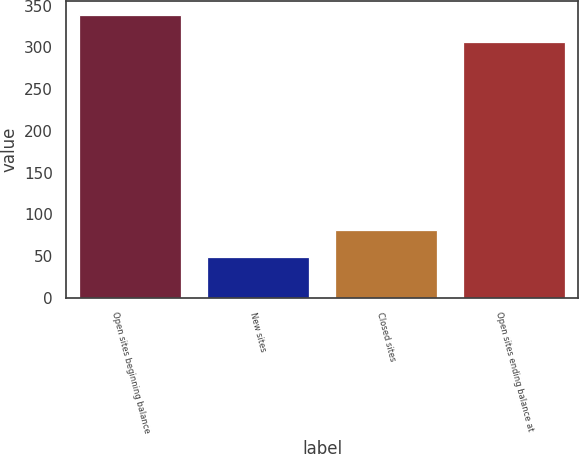Convert chart to OTSL. <chart><loc_0><loc_0><loc_500><loc_500><bar_chart><fcel>Open sites beginning balance<fcel>New sites<fcel>Closed sites<fcel>Open sites ending balance at<nl><fcel>339<fcel>49<fcel>81<fcel>307<nl></chart> 